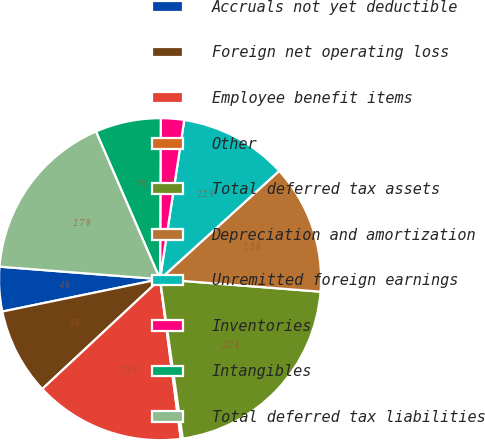Convert chart to OTSL. <chart><loc_0><loc_0><loc_500><loc_500><pie_chart><fcel>Accruals not yet deductible<fcel>Foreign net operating loss<fcel>Employee benefit items<fcel>Other<fcel>Total deferred tax assets<fcel>Depreciation and amortization<fcel>Unremitted foreign earnings<fcel>Inventories<fcel>Intangibles<fcel>Total deferred tax liabilities<nl><fcel>4.46%<fcel>8.72%<fcel>15.11%<fcel>0.2%<fcel>21.5%<fcel>12.98%<fcel>10.85%<fcel>2.33%<fcel>6.59%<fcel>17.24%<nl></chart> 